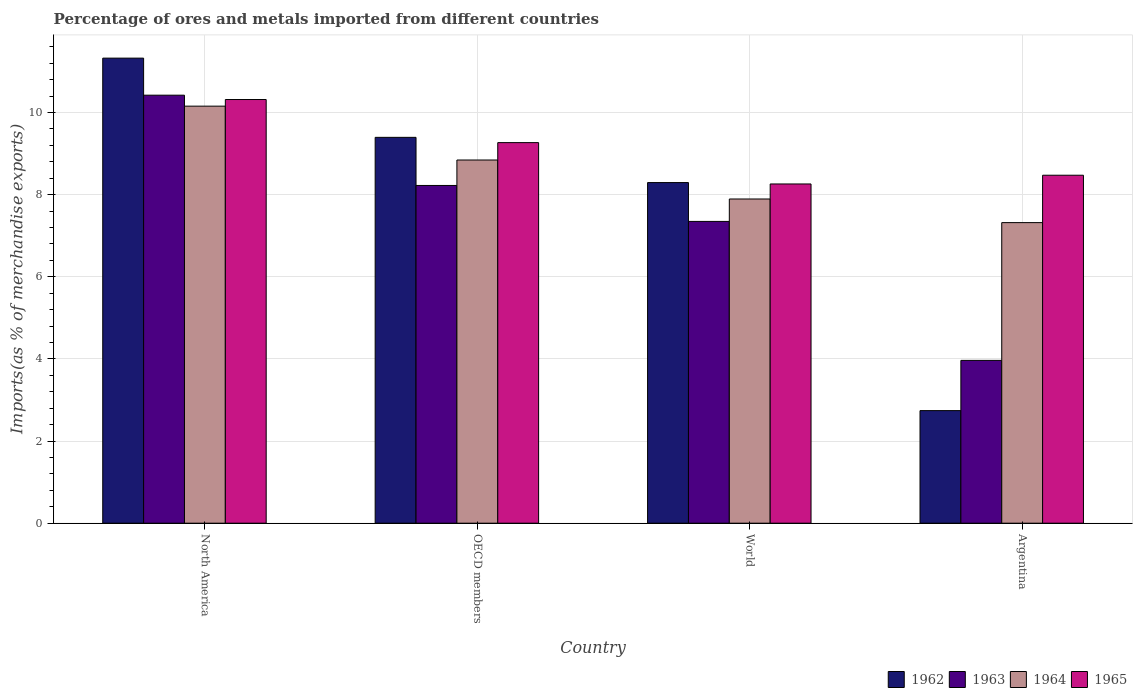How many different coloured bars are there?
Offer a very short reply. 4. How many groups of bars are there?
Your answer should be very brief. 4. How many bars are there on the 2nd tick from the left?
Offer a very short reply. 4. What is the percentage of imports to different countries in 1964 in North America?
Offer a very short reply. 10.15. Across all countries, what is the maximum percentage of imports to different countries in 1963?
Give a very brief answer. 10.42. Across all countries, what is the minimum percentage of imports to different countries in 1962?
Make the answer very short. 2.74. In which country was the percentage of imports to different countries in 1962 maximum?
Keep it short and to the point. North America. What is the total percentage of imports to different countries in 1963 in the graph?
Offer a terse response. 29.95. What is the difference between the percentage of imports to different countries in 1965 in OECD members and that in World?
Provide a short and direct response. 1.01. What is the difference between the percentage of imports to different countries in 1963 in World and the percentage of imports to different countries in 1964 in Argentina?
Your answer should be compact. 0.03. What is the average percentage of imports to different countries in 1965 per country?
Provide a succinct answer. 9.08. What is the difference between the percentage of imports to different countries of/in 1962 and percentage of imports to different countries of/in 1964 in World?
Your answer should be compact. 0.4. What is the ratio of the percentage of imports to different countries in 1964 in OECD members to that in World?
Give a very brief answer. 1.12. Is the difference between the percentage of imports to different countries in 1962 in Argentina and World greater than the difference between the percentage of imports to different countries in 1964 in Argentina and World?
Your response must be concise. No. What is the difference between the highest and the second highest percentage of imports to different countries in 1962?
Offer a terse response. -1.1. What is the difference between the highest and the lowest percentage of imports to different countries in 1964?
Provide a succinct answer. 2.84. Is the sum of the percentage of imports to different countries in 1963 in Argentina and North America greater than the maximum percentage of imports to different countries in 1962 across all countries?
Ensure brevity in your answer.  Yes. What does the 3rd bar from the left in North America represents?
Keep it short and to the point. 1964. Is it the case that in every country, the sum of the percentage of imports to different countries in 1965 and percentage of imports to different countries in 1964 is greater than the percentage of imports to different countries in 1962?
Your response must be concise. Yes. How many bars are there?
Provide a short and direct response. 16. Are all the bars in the graph horizontal?
Provide a short and direct response. No. How many countries are there in the graph?
Offer a very short reply. 4. What is the difference between two consecutive major ticks on the Y-axis?
Offer a terse response. 2. Are the values on the major ticks of Y-axis written in scientific E-notation?
Your answer should be very brief. No. Does the graph contain any zero values?
Give a very brief answer. No. Does the graph contain grids?
Provide a short and direct response. Yes. What is the title of the graph?
Make the answer very short. Percentage of ores and metals imported from different countries. Does "1960" appear as one of the legend labels in the graph?
Give a very brief answer. No. What is the label or title of the Y-axis?
Provide a short and direct response. Imports(as % of merchandise exports). What is the Imports(as % of merchandise exports) of 1962 in North America?
Provide a short and direct response. 11.32. What is the Imports(as % of merchandise exports) in 1963 in North America?
Ensure brevity in your answer.  10.42. What is the Imports(as % of merchandise exports) in 1964 in North America?
Offer a very short reply. 10.15. What is the Imports(as % of merchandise exports) in 1965 in North America?
Keep it short and to the point. 10.31. What is the Imports(as % of merchandise exports) in 1962 in OECD members?
Provide a succinct answer. 9.39. What is the Imports(as % of merchandise exports) in 1963 in OECD members?
Ensure brevity in your answer.  8.22. What is the Imports(as % of merchandise exports) in 1964 in OECD members?
Your answer should be compact. 8.84. What is the Imports(as % of merchandise exports) of 1965 in OECD members?
Ensure brevity in your answer.  9.27. What is the Imports(as % of merchandise exports) in 1962 in World?
Provide a succinct answer. 8.29. What is the Imports(as % of merchandise exports) in 1963 in World?
Ensure brevity in your answer.  7.35. What is the Imports(as % of merchandise exports) in 1964 in World?
Provide a succinct answer. 7.89. What is the Imports(as % of merchandise exports) in 1965 in World?
Keep it short and to the point. 8.26. What is the Imports(as % of merchandise exports) in 1962 in Argentina?
Make the answer very short. 2.74. What is the Imports(as % of merchandise exports) of 1963 in Argentina?
Ensure brevity in your answer.  3.96. What is the Imports(as % of merchandise exports) of 1964 in Argentina?
Your answer should be very brief. 7.32. What is the Imports(as % of merchandise exports) in 1965 in Argentina?
Provide a succinct answer. 8.47. Across all countries, what is the maximum Imports(as % of merchandise exports) of 1962?
Offer a terse response. 11.32. Across all countries, what is the maximum Imports(as % of merchandise exports) of 1963?
Your answer should be very brief. 10.42. Across all countries, what is the maximum Imports(as % of merchandise exports) in 1964?
Provide a succinct answer. 10.15. Across all countries, what is the maximum Imports(as % of merchandise exports) in 1965?
Offer a very short reply. 10.31. Across all countries, what is the minimum Imports(as % of merchandise exports) of 1962?
Give a very brief answer. 2.74. Across all countries, what is the minimum Imports(as % of merchandise exports) of 1963?
Ensure brevity in your answer.  3.96. Across all countries, what is the minimum Imports(as % of merchandise exports) of 1964?
Make the answer very short. 7.32. Across all countries, what is the minimum Imports(as % of merchandise exports) of 1965?
Make the answer very short. 8.26. What is the total Imports(as % of merchandise exports) of 1962 in the graph?
Your answer should be very brief. 31.75. What is the total Imports(as % of merchandise exports) of 1963 in the graph?
Your answer should be compact. 29.95. What is the total Imports(as % of merchandise exports) of 1964 in the graph?
Offer a very short reply. 34.21. What is the total Imports(as % of merchandise exports) in 1965 in the graph?
Offer a terse response. 36.31. What is the difference between the Imports(as % of merchandise exports) in 1962 in North America and that in OECD members?
Make the answer very short. 1.93. What is the difference between the Imports(as % of merchandise exports) in 1963 in North America and that in OECD members?
Ensure brevity in your answer.  2.2. What is the difference between the Imports(as % of merchandise exports) of 1964 in North America and that in OECD members?
Keep it short and to the point. 1.31. What is the difference between the Imports(as % of merchandise exports) of 1965 in North America and that in OECD members?
Make the answer very short. 1.05. What is the difference between the Imports(as % of merchandise exports) of 1962 in North America and that in World?
Your answer should be very brief. 3.03. What is the difference between the Imports(as % of merchandise exports) in 1963 in North America and that in World?
Your response must be concise. 3.07. What is the difference between the Imports(as % of merchandise exports) of 1964 in North America and that in World?
Your answer should be compact. 2.26. What is the difference between the Imports(as % of merchandise exports) in 1965 in North America and that in World?
Ensure brevity in your answer.  2.06. What is the difference between the Imports(as % of merchandise exports) of 1962 in North America and that in Argentina?
Make the answer very short. 8.58. What is the difference between the Imports(as % of merchandise exports) in 1963 in North America and that in Argentina?
Your response must be concise. 6.46. What is the difference between the Imports(as % of merchandise exports) in 1964 in North America and that in Argentina?
Your response must be concise. 2.84. What is the difference between the Imports(as % of merchandise exports) of 1965 in North America and that in Argentina?
Keep it short and to the point. 1.84. What is the difference between the Imports(as % of merchandise exports) in 1962 in OECD members and that in World?
Keep it short and to the point. 1.1. What is the difference between the Imports(as % of merchandise exports) in 1963 in OECD members and that in World?
Your response must be concise. 0.88. What is the difference between the Imports(as % of merchandise exports) of 1964 in OECD members and that in World?
Ensure brevity in your answer.  0.95. What is the difference between the Imports(as % of merchandise exports) of 1965 in OECD members and that in World?
Your answer should be compact. 1.01. What is the difference between the Imports(as % of merchandise exports) of 1962 in OECD members and that in Argentina?
Keep it short and to the point. 6.65. What is the difference between the Imports(as % of merchandise exports) in 1963 in OECD members and that in Argentina?
Offer a terse response. 4.26. What is the difference between the Imports(as % of merchandise exports) in 1964 in OECD members and that in Argentina?
Make the answer very short. 1.52. What is the difference between the Imports(as % of merchandise exports) of 1965 in OECD members and that in Argentina?
Your response must be concise. 0.79. What is the difference between the Imports(as % of merchandise exports) in 1962 in World and that in Argentina?
Your response must be concise. 5.55. What is the difference between the Imports(as % of merchandise exports) in 1963 in World and that in Argentina?
Give a very brief answer. 3.38. What is the difference between the Imports(as % of merchandise exports) in 1964 in World and that in Argentina?
Keep it short and to the point. 0.58. What is the difference between the Imports(as % of merchandise exports) in 1965 in World and that in Argentina?
Make the answer very short. -0.21. What is the difference between the Imports(as % of merchandise exports) in 1962 in North America and the Imports(as % of merchandise exports) in 1963 in OECD members?
Offer a terse response. 3.1. What is the difference between the Imports(as % of merchandise exports) in 1962 in North America and the Imports(as % of merchandise exports) in 1964 in OECD members?
Your response must be concise. 2.48. What is the difference between the Imports(as % of merchandise exports) of 1962 in North America and the Imports(as % of merchandise exports) of 1965 in OECD members?
Your answer should be compact. 2.06. What is the difference between the Imports(as % of merchandise exports) in 1963 in North America and the Imports(as % of merchandise exports) in 1964 in OECD members?
Keep it short and to the point. 1.58. What is the difference between the Imports(as % of merchandise exports) in 1963 in North America and the Imports(as % of merchandise exports) in 1965 in OECD members?
Keep it short and to the point. 1.16. What is the difference between the Imports(as % of merchandise exports) in 1964 in North America and the Imports(as % of merchandise exports) in 1965 in OECD members?
Provide a succinct answer. 0.89. What is the difference between the Imports(as % of merchandise exports) in 1962 in North America and the Imports(as % of merchandise exports) in 1963 in World?
Provide a short and direct response. 3.98. What is the difference between the Imports(as % of merchandise exports) of 1962 in North America and the Imports(as % of merchandise exports) of 1964 in World?
Your answer should be very brief. 3.43. What is the difference between the Imports(as % of merchandise exports) in 1962 in North America and the Imports(as % of merchandise exports) in 1965 in World?
Provide a succinct answer. 3.06. What is the difference between the Imports(as % of merchandise exports) in 1963 in North America and the Imports(as % of merchandise exports) in 1964 in World?
Offer a terse response. 2.53. What is the difference between the Imports(as % of merchandise exports) of 1963 in North America and the Imports(as % of merchandise exports) of 1965 in World?
Your response must be concise. 2.16. What is the difference between the Imports(as % of merchandise exports) of 1964 in North America and the Imports(as % of merchandise exports) of 1965 in World?
Your answer should be very brief. 1.89. What is the difference between the Imports(as % of merchandise exports) in 1962 in North America and the Imports(as % of merchandise exports) in 1963 in Argentina?
Ensure brevity in your answer.  7.36. What is the difference between the Imports(as % of merchandise exports) in 1962 in North America and the Imports(as % of merchandise exports) in 1964 in Argentina?
Provide a short and direct response. 4. What is the difference between the Imports(as % of merchandise exports) of 1962 in North America and the Imports(as % of merchandise exports) of 1965 in Argentina?
Offer a very short reply. 2.85. What is the difference between the Imports(as % of merchandise exports) of 1963 in North America and the Imports(as % of merchandise exports) of 1964 in Argentina?
Ensure brevity in your answer.  3.1. What is the difference between the Imports(as % of merchandise exports) in 1963 in North America and the Imports(as % of merchandise exports) in 1965 in Argentina?
Offer a very short reply. 1.95. What is the difference between the Imports(as % of merchandise exports) in 1964 in North America and the Imports(as % of merchandise exports) in 1965 in Argentina?
Your answer should be very brief. 1.68. What is the difference between the Imports(as % of merchandise exports) in 1962 in OECD members and the Imports(as % of merchandise exports) in 1963 in World?
Provide a succinct answer. 2.05. What is the difference between the Imports(as % of merchandise exports) in 1962 in OECD members and the Imports(as % of merchandise exports) in 1964 in World?
Offer a terse response. 1.5. What is the difference between the Imports(as % of merchandise exports) in 1962 in OECD members and the Imports(as % of merchandise exports) in 1965 in World?
Your response must be concise. 1.13. What is the difference between the Imports(as % of merchandise exports) in 1963 in OECD members and the Imports(as % of merchandise exports) in 1964 in World?
Provide a succinct answer. 0.33. What is the difference between the Imports(as % of merchandise exports) of 1963 in OECD members and the Imports(as % of merchandise exports) of 1965 in World?
Offer a terse response. -0.04. What is the difference between the Imports(as % of merchandise exports) of 1964 in OECD members and the Imports(as % of merchandise exports) of 1965 in World?
Offer a very short reply. 0.58. What is the difference between the Imports(as % of merchandise exports) in 1962 in OECD members and the Imports(as % of merchandise exports) in 1963 in Argentina?
Your answer should be very brief. 5.43. What is the difference between the Imports(as % of merchandise exports) of 1962 in OECD members and the Imports(as % of merchandise exports) of 1964 in Argentina?
Provide a succinct answer. 2.08. What is the difference between the Imports(as % of merchandise exports) in 1962 in OECD members and the Imports(as % of merchandise exports) in 1965 in Argentina?
Make the answer very short. 0.92. What is the difference between the Imports(as % of merchandise exports) of 1963 in OECD members and the Imports(as % of merchandise exports) of 1964 in Argentina?
Your answer should be very brief. 0.9. What is the difference between the Imports(as % of merchandise exports) in 1963 in OECD members and the Imports(as % of merchandise exports) in 1965 in Argentina?
Make the answer very short. -0.25. What is the difference between the Imports(as % of merchandise exports) in 1964 in OECD members and the Imports(as % of merchandise exports) in 1965 in Argentina?
Make the answer very short. 0.37. What is the difference between the Imports(as % of merchandise exports) of 1962 in World and the Imports(as % of merchandise exports) of 1963 in Argentina?
Provide a succinct answer. 4.33. What is the difference between the Imports(as % of merchandise exports) in 1962 in World and the Imports(as % of merchandise exports) in 1964 in Argentina?
Your answer should be compact. 0.98. What is the difference between the Imports(as % of merchandise exports) in 1962 in World and the Imports(as % of merchandise exports) in 1965 in Argentina?
Offer a very short reply. -0.18. What is the difference between the Imports(as % of merchandise exports) in 1963 in World and the Imports(as % of merchandise exports) in 1964 in Argentina?
Keep it short and to the point. 0.03. What is the difference between the Imports(as % of merchandise exports) in 1963 in World and the Imports(as % of merchandise exports) in 1965 in Argentina?
Give a very brief answer. -1.12. What is the difference between the Imports(as % of merchandise exports) of 1964 in World and the Imports(as % of merchandise exports) of 1965 in Argentina?
Keep it short and to the point. -0.58. What is the average Imports(as % of merchandise exports) of 1962 per country?
Provide a short and direct response. 7.94. What is the average Imports(as % of merchandise exports) of 1963 per country?
Give a very brief answer. 7.49. What is the average Imports(as % of merchandise exports) of 1964 per country?
Your response must be concise. 8.55. What is the average Imports(as % of merchandise exports) in 1965 per country?
Your answer should be very brief. 9.08. What is the difference between the Imports(as % of merchandise exports) in 1962 and Imports(as % of merchandise exports) in 1963 in North America?
Keep it short and to the point. 0.9. What is the difference between the Imports(as % of merchandise exports) of 1962 and Imports(as % of merchandise exports) of 1964 in North America?
Make the answer very short. 1.17. What is the difference between the Imports(as % of merchandise exports) in 1962 and Imports(as % of merchandise exports) in 1965 in North America?
Give a very brief answer. 1.01. What is the difference between the Imports(as % of merchandise exports) in 1963 and Imports(as % of merchandise exports) in 1964 in North America?
Keep it short and to the point. 0.27. What is the difference between the Imports(as % of merchandise exports) of 1963 and Imports(as % of merchandise exports) of 1965 in North America?
Make the answer very short. 0.11. What is the difference between the Imports(as % of merchandise exports) in 1964 and Imports(as % of merchandise exports) in 1965 in North America?
Offer a very short reply. -0.16. What is the difference between the Imports(as % of merchandise exports) of 1962 and Imports(as % of merchandise exports) of 1963 in OECD members?
Your response must be concise. 1.17. What is the difference between the Imports(as % of merchandise exports) of 1962 and Imports(as % of merchandise exports) of 1964 in OECD members?
Offer a very short reply. 0.55. What is the difference between the Imports(as % of merchandise exports) of 1962 and Imports(as % of merchandise exports) of 1965 in OECD members?
Your answer should be very brief. 0.13. What is the difference between the Imports(as % of merchandise exports) in 1963 and Imports(as % of merchandise exports) in 1964 in OECD members?
Make the answer very short. -0.62. What is the difference between the Imports(as % of merchandise exports) in 1963 and Imports(as % of merchandise exports) in 1965 in OECD members?
Keep it short and to the point. -1.04. What is the difference between the Imports(as % of merchandise exports) of 1964 and Imports(as % of merchandise exports) of 1965 in OECD members?
Provide a short and direct response. -0.42. What is the difference between the Imports(as % of merchandise exports) of 1962 and Imports(as % of merchandise exports) of 1963 in World?
Give a very brief answer. 0.95. What is the difference between the Imports(as % of merchandise exports) in 1962 and Imports(as % of merchandise exports) in 1964 in World?
Make the answer very short. 0.4. What is the difference between the Imports(as % of merchandise exports) in 1962 and Imports(as % of merchandise exports) in 1965 in World?
Make the answer very short. 0.03. What is the difference between the Imports(as % of merchandise exports) in 1963 and Imports(as % of merchandise exports) in 1964 in World?
Your answer should be compact. -0.55. What is the difference between the Imports(as % of merchandise exports) in 1963 and Imports(as % of merchandise exports) in 1965 in World?
Your answer should be very brief. -0.91. What is the difference between the Imports(as % of merchandise exports) in 1964 and Imports(as % of merchandise exports) in 1965 in World?
Your answer should be very brief. -0.37. What is the difference between the Imports(as % of merchandise exports) of 1962 and Imports(as % of merchandise exports) of 1963 in Argentina?
Provide a short and direct response. -1.22. What is the difference between the Imports(as % of merchandise exports) in 1962 and Imports(as % of merchandise exports) in 1964 in Argentina?
Provide a succinct answer. -4.58. What is the difference between the Imports(as % of merchandise exports) in 1962 and Imports(as % of merchandise exports) in 1965 in Argentina?
Make the answer very short. -5.73. What is the difference between the Imports(as % of merchandise exports) in 1963 and Imports(as % of merchandise exports) in 1964 in Argentina?
Provide a succinct answer. -3.35. What is the difference between the Imports(as % of merchandise exports) of 1963 and Imports(as % of merchandise exports) of 1965 in Argentina?
Provide a succinct answer. -4.51. What is the difference between the Imports(as % of merchandise exports) in 1964 and Imports(as % of merchandise exports) in 1965 in Argentina?
Keep it short and to the point. -1.15. What is the ratio of the Imports(as % of merchandise exports) of 1962 in North America to that in OECD members?
Provide a short and direct response. 1.21. What is the ratio of the Imports(as % of merchandise exports) of 1963 in North America to that in OECD members?
Provide a short and direct response. 1.27. What is the ratio of the Imports(as % of merchandise exports) in 1964 in North America to that in OECD members?
Offer a terse response. 1.15. What is the ratio of the Imports(as % of merchandise exports) in 1965 in North America to that in OECD members?
Provide a succinct answer. 1.11. What is the ratio of the Imports(as % of merchandise exports) of 1962 in North America to that in World?
Give a very brief answer. 1.37. What is the ratio of the Imports(as % of merchandise exports) in 1963 in North America to that in World?
Keep it short and to the point. 1.42. What is the ratio of the Imports(as % of merchandise exports) in 1964 in North America to that in World?
Offer a very short reply. 1.29. What is the ratio of the Imports(as % of merchandise exports) of 1965 in North America to that in World?
Provide a short and direct response. 1.25. What is the ratio of the Imports(as % of merchandise exports) in 1962 in North America to that in Argentina?
Your answer should be compact. 4.13. What is the ratio of the Imports(as % of merchandise exports) in 1963 in North America to that in Argentina?
Offer a very short reply. 2.63. What is the ratio of the Imports(as % of merchandise exports) of 1964 in North America to that in Argentina?
Keep it short and to the point. 1.39. What is the ratio of the Imports(as % of merchandise exports) of 1965 in North America to that in Argentina?
Offer a terse response. 1.22. What is the ratio of the Imports(as % of merchandise exports) in 1962 in OECD members to that in World?
Offer a terse response. 1.13. What is the ratio of the Imports(as % of merchandise exports) in 1963 in OECD members to that in World?
Provide a short and direct response. 1.12. What is the ratio of the Imports(as % of merchandise exports) of 1964 in OECD members to that in World?
Provide a short and direct response. 1.12. What is the ratio of the Imports(as % of merchandise exports) in 1965 in OECD members to that in World?
Your answer should be very brief. 1.12. What is the ratio of the Imports(as % of merchandise exports) of 1962 in OECD members to that in Argentina?
Provide a succinct answer. 3.43. What is the ratio of the Imports(as % of merchandise exports) in 1963 in OECD members to that in Argentina?
Ensure brevity in your answer.  2.07. What is the ratio of the Imports(as % of merchandise exports) of 1964 in OECD members to that in Argentina?
Your response must be concise. 1.21. What is the ratio of the Imports(as % of merchandise exports) in 1965 in OECD members to that in Argentina?
Your response must be concise. 1.09. What is the ratio of the Imports(as % of merchandise exports) in 1962 in World to that in Argentina?
Ensure brevity in your answer.  3.03. What is the ratio of the Imports(as % of merchandise exports) in 1963 in World to that in Argentina?
Your response must be concise. 1.85. What is the ratio of the Imports(as % of merchandise exports) in 1964 in World to that in Argentina?
Your answer should be compact. 1.08. What is the ratio of the Imports(as % of merchandise exports) in 1965 in World to that in Argentina?
Make the answer very short. 0.97. What is the difference between the highest and the second highest Imports(as % of merchandise exports) of 1962?
Offer a very short reply. 1.93. What is the difference between the highest and the second highest Imports(as % of merchandise exports) of 1963?
Provide a succinct answer. 2.2. What is the difference between the highest and the second highest Imports(as % of merchandise exports) in 1964?
Provide a short and direct response. 1.31. What is the difference between the highest and the second highest Imports(as % of merchandise exports) in 1965?
Keep it short and to the point. 1.05. What is the difference between the highest and the lowest Imports(as % of merchandise exports) of 1962?
Your response must be concise. 8.58. What is the difference between the highest and the lowest Imports(as % of merchandise exports) of 1963?
Your answer should be compact. 6.46. What is the difference between the highest and the lowest Imports(as % of merchandise exports) of 1964?
Your answer should be very brief. 2.84. What is the difference between the highest and the lowest Imports(as % of merchandise exports) of 1965?
Your answer should be very brief. 2.06. 